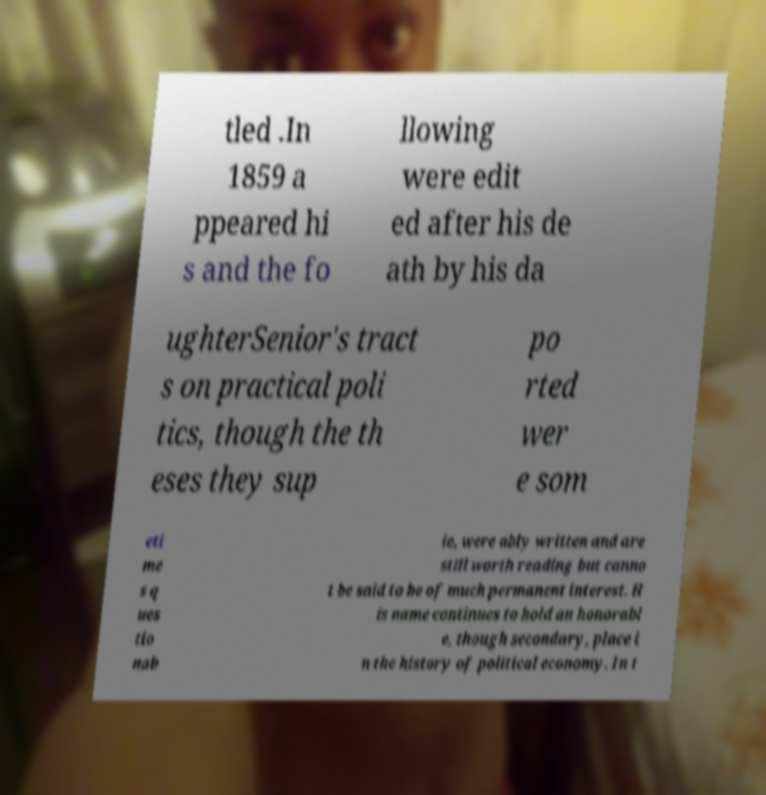Could you assist in decoding the text presented in this image and type it out clearly? tled .In 1859 a ppeared hi s and the fo llowing were edit ed after his de ath by his da ughterSenior's tract s on practical poli tics, though the th eses they sup po rted wer e som eti me s q ues tio nab le, were ably written and are still worth reading but canno t be said to be of much permanent interest. H is name continues to hold an honorabl e, though secondary, place i n the history of political economy. In t 